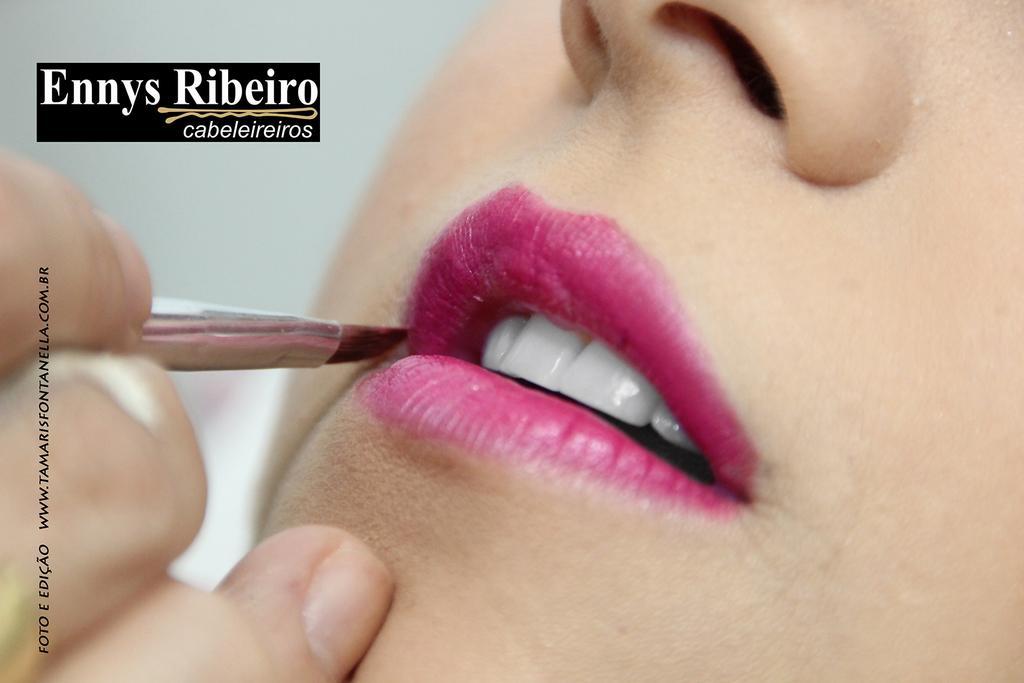Please provide a concise description of this image. In this image there is a woman's face towards the right of the image, there is a hand towards the left of the image, there is an object in the hand, there is text towards the top of the image, there is towards the left of the image, the background of the image is white in color. 